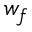<formula> <loc_0><loc_0><loc_500><loc_500>w _ { f }</formula> 